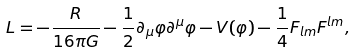<formula> <loc_0><loc_0><loc_500><loc_500>L = - \frac { R } { 1 6 \pi G } - \frac { 1 } { 2 } \partial _ { \mu } \varphi \partial ^ { \mu } \varphi - V ( \varphi ) - \frac { 1 } { 4 } F _ { l m } F ^ { l m } ,</formula> 